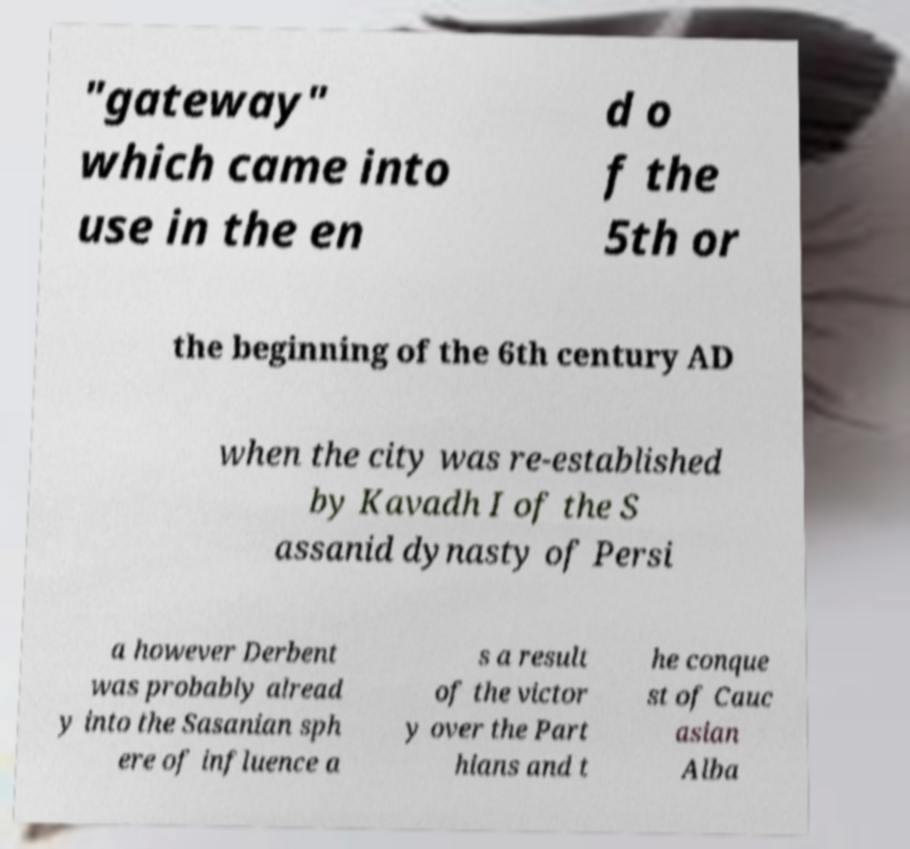Please identify and transcribe the text found in this image. "gateway" which came into use in the en d o f the 5th or the beginning of the 6th century AD when the city was re-established by Kavadh I of the S assanid dynasty of Persi a however Derbent was probably alread y into the Sasanian sph ere of influence a s a result of the victor y over the Part hians and t he conque st of Cauc asian Alba 